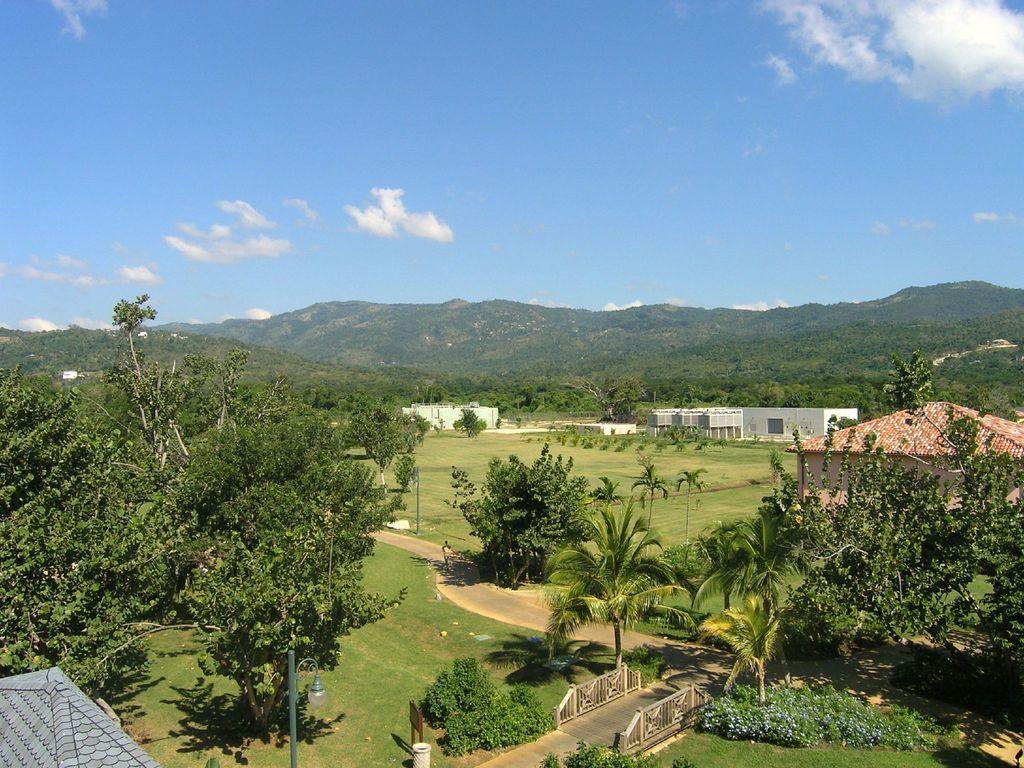How would you summarize this image in a sentence or two? In this image I can see trees in green color, background I can see a house in white color and the sky is in blue and white color. 